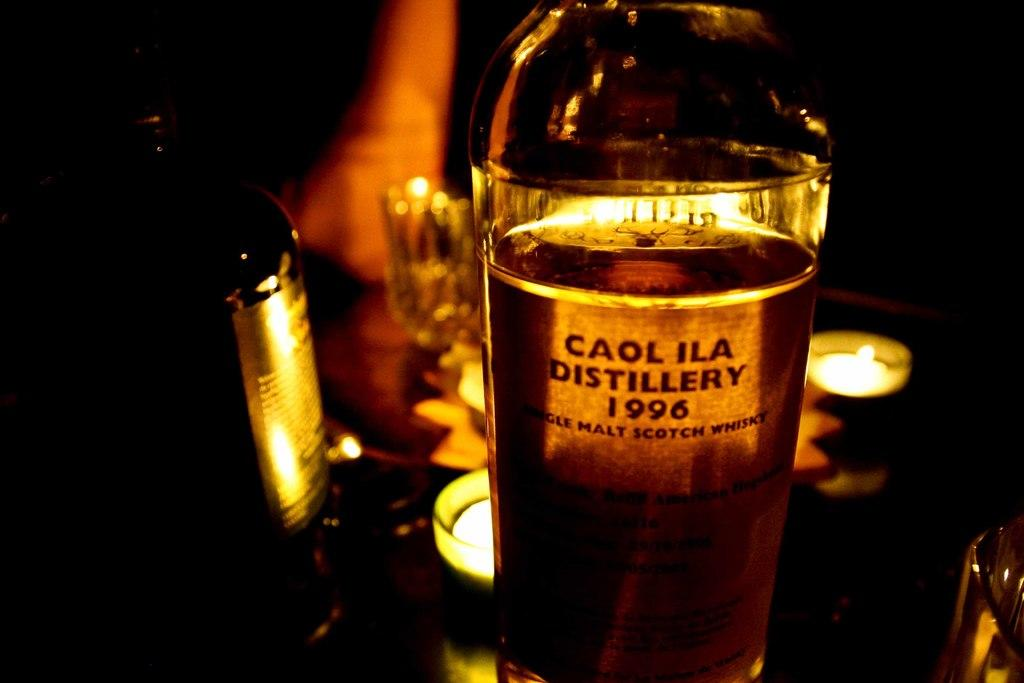How many bottles are visible in the image? There are two bottles in the image. What other object can be seen on the table? There is a glass in the image. What type of objects are used for lighting in the image? There are candles in the image. Where are all the objects located in the image? All objects are on a table. What type of grain is being harvested by the crowd in the image? There is no crowd or grain present in the image; it only features two bottles, a glass, and candles on a table. 